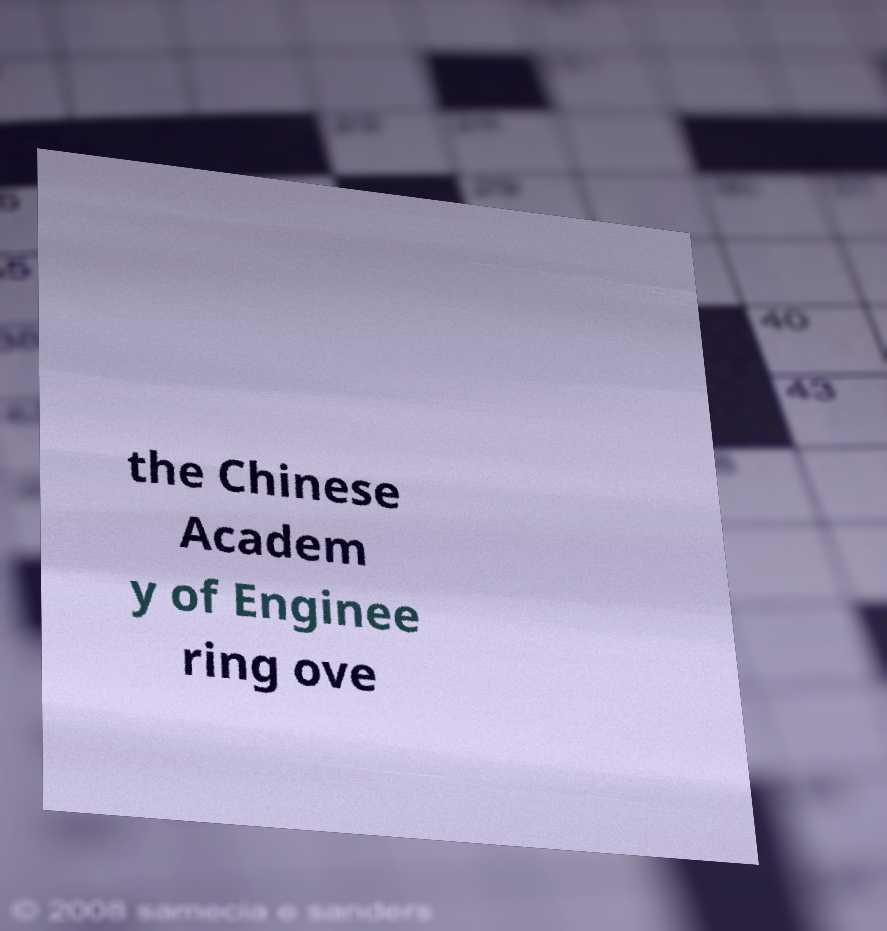Could you extract and type out the text from this image? the Chinese Academ y of Enginee ring ove 